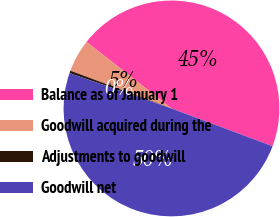Convert chart to OTSL. <chart><loc_0><loc_0><loc_500><loc_500><pie_chart><fcel>Balance as of January 1<fcel>Goodwill acquired during the<fcel>Adjustments to goodwill<fcel>Goodwill net<nl><fcel>45.12%<fcel>4.88%<fcel>0.38%<fcel>49.62%<nl></chart> 